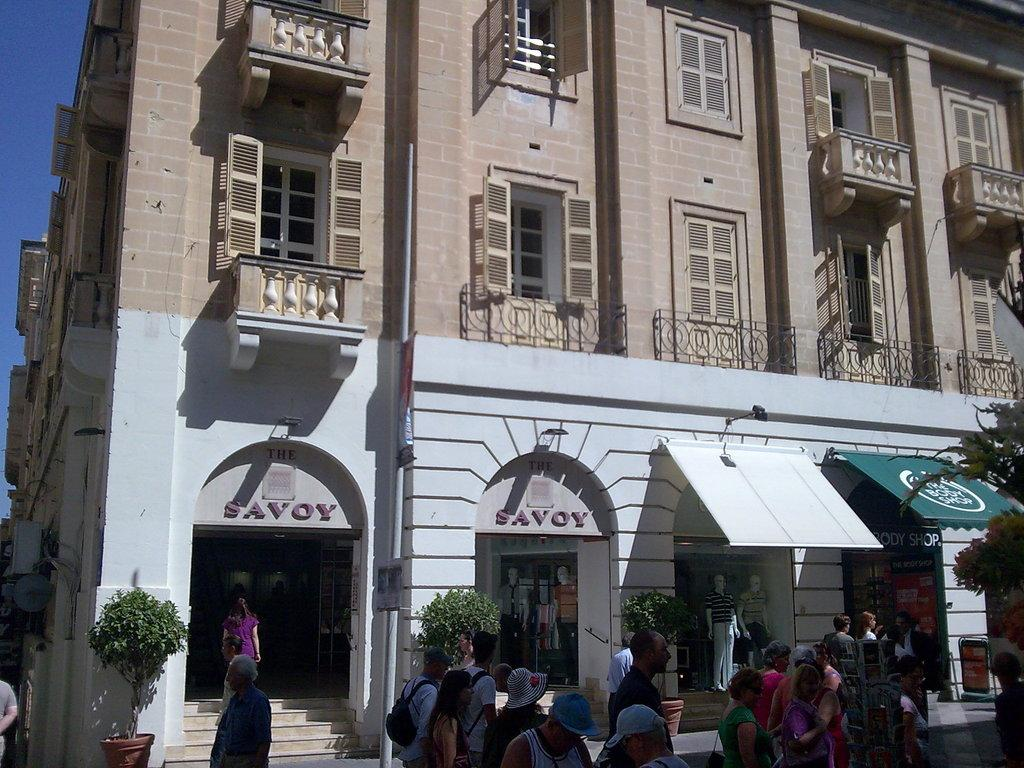What type of structure is present in the image? There is a building in the image. What can be found inside the building? The building contains stores. Is there any text visible on the building? Yes, there is text written on the building. Can you describe the people in the image? There is a group of people in front of the building. Where are the books located in the image? There is no mention of books in the image, so we cannot determine their location. 